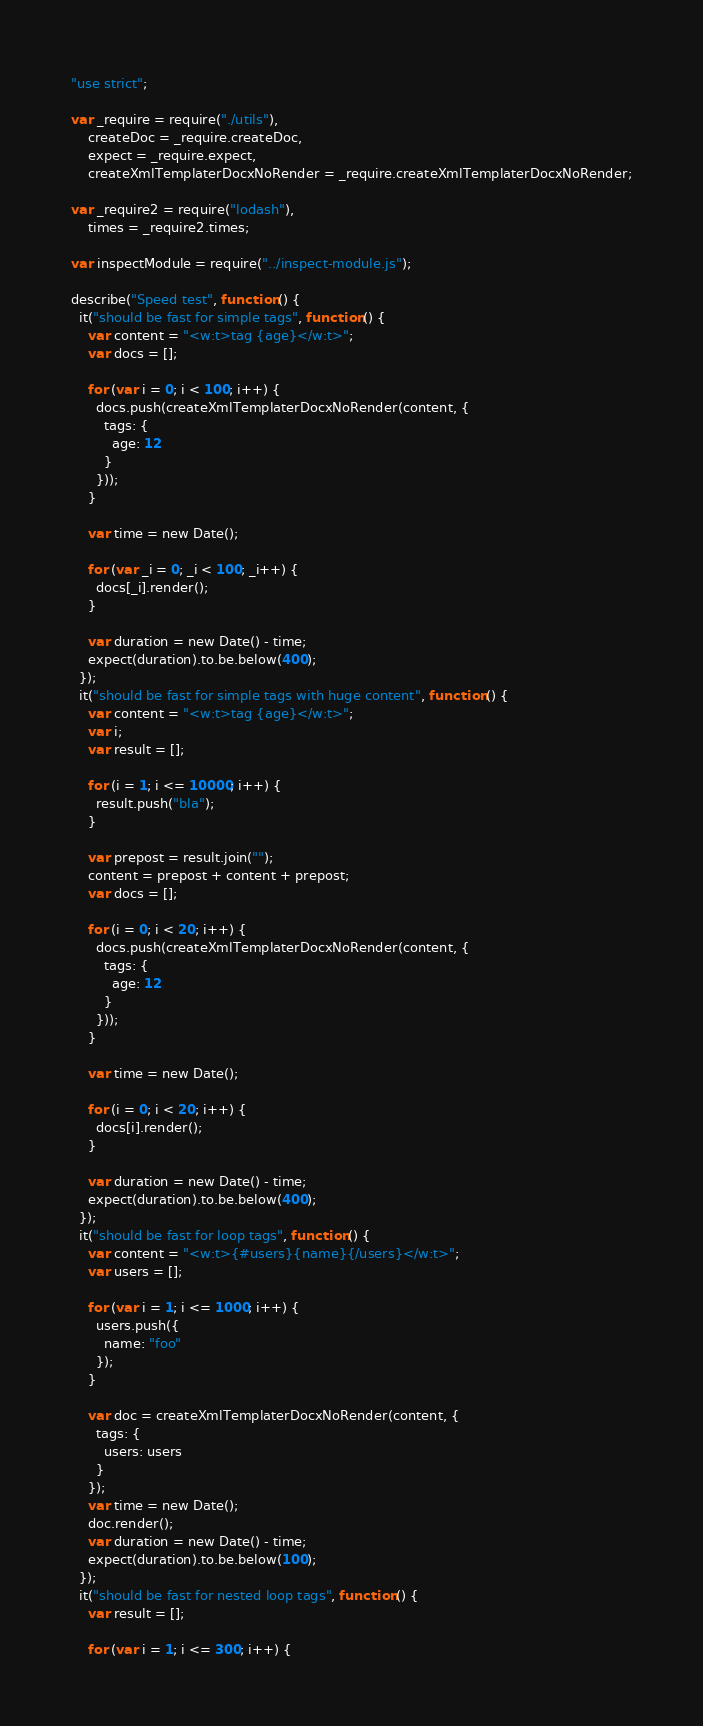Convert code to text. <code><loc_0><loc_0><loc_500><loc_500><_JavaScript_>"use strict";

var _require = require("./utils"),
    createDoc = _require.createDoc,
    expect = _require.expect,
    createXmlTemplaterDocxNoRender = _require.createXmlTemplaterDocxNoRender;

var _require2 = require("lodash"),
    times = _require2.times;

var inspectModule = require("../inspect-module.js");

describe("Speed test", function () {
  it("should be fast for simple tags", function () {
    var content = "<w:t>tag {age}</w:t>";
    var docs = [];

    for (var i = 0; i < 100; i++) {
      docs.push(createXmlTemplaterDocxNoRender(content, {
        tags: {
          age: 12
        }
      }));
    }

    var time = new Date();

    for (var _i = 0; _i < 100; _i++) {
      docs[_i].render();
    }

    var duration = new Date() - time;
    expect(duration).to.be.below(400);
  });
  it("should be fast for simple tags with huge content", function () {
    var content = "<w:t>tag {age}</w:t>";
    var i;
    var result = [];

    for (i = 1; i <= 10000; i++) {
      result.push("bla");
    }

    var prepost = result.join("");
    content = prepost + content + prepost;
    var docs = [];

    for (i = 0; i < 20; i++) {
      docs.push(createXmlTemplaterDocxNoRender(content, {
        tags: {
          age: 12
        }
      }));
    }

    var time = new Date();

    for (i = 0; i < 20; i++) {
      docs[i].render();
    }

    var duration = new Date() - time;
    expect(duration).to.be.below(400);
  });
  it("should be fast for loop tags", function () {
    var content = "<w:t>{#users}{name}{/users}</w:t>";
    var users = [];

    for (var i = 1; i <= 1000; i++) {
      users.push({
        name: "foo"
      });
    }

    var doc = createXmlTemplaterDocxNoRender(content, {
      tags: {
        users: users
      }
    });
    var time = new Date();
    doc.render();
    var duration = new Date() - time;
    expect(duration).to.be.below(100);
  });
  it("should be fast for nested loop tags", function () {
    var result = [];

    for (var i = 1; i <= 300; i++) {</code> 